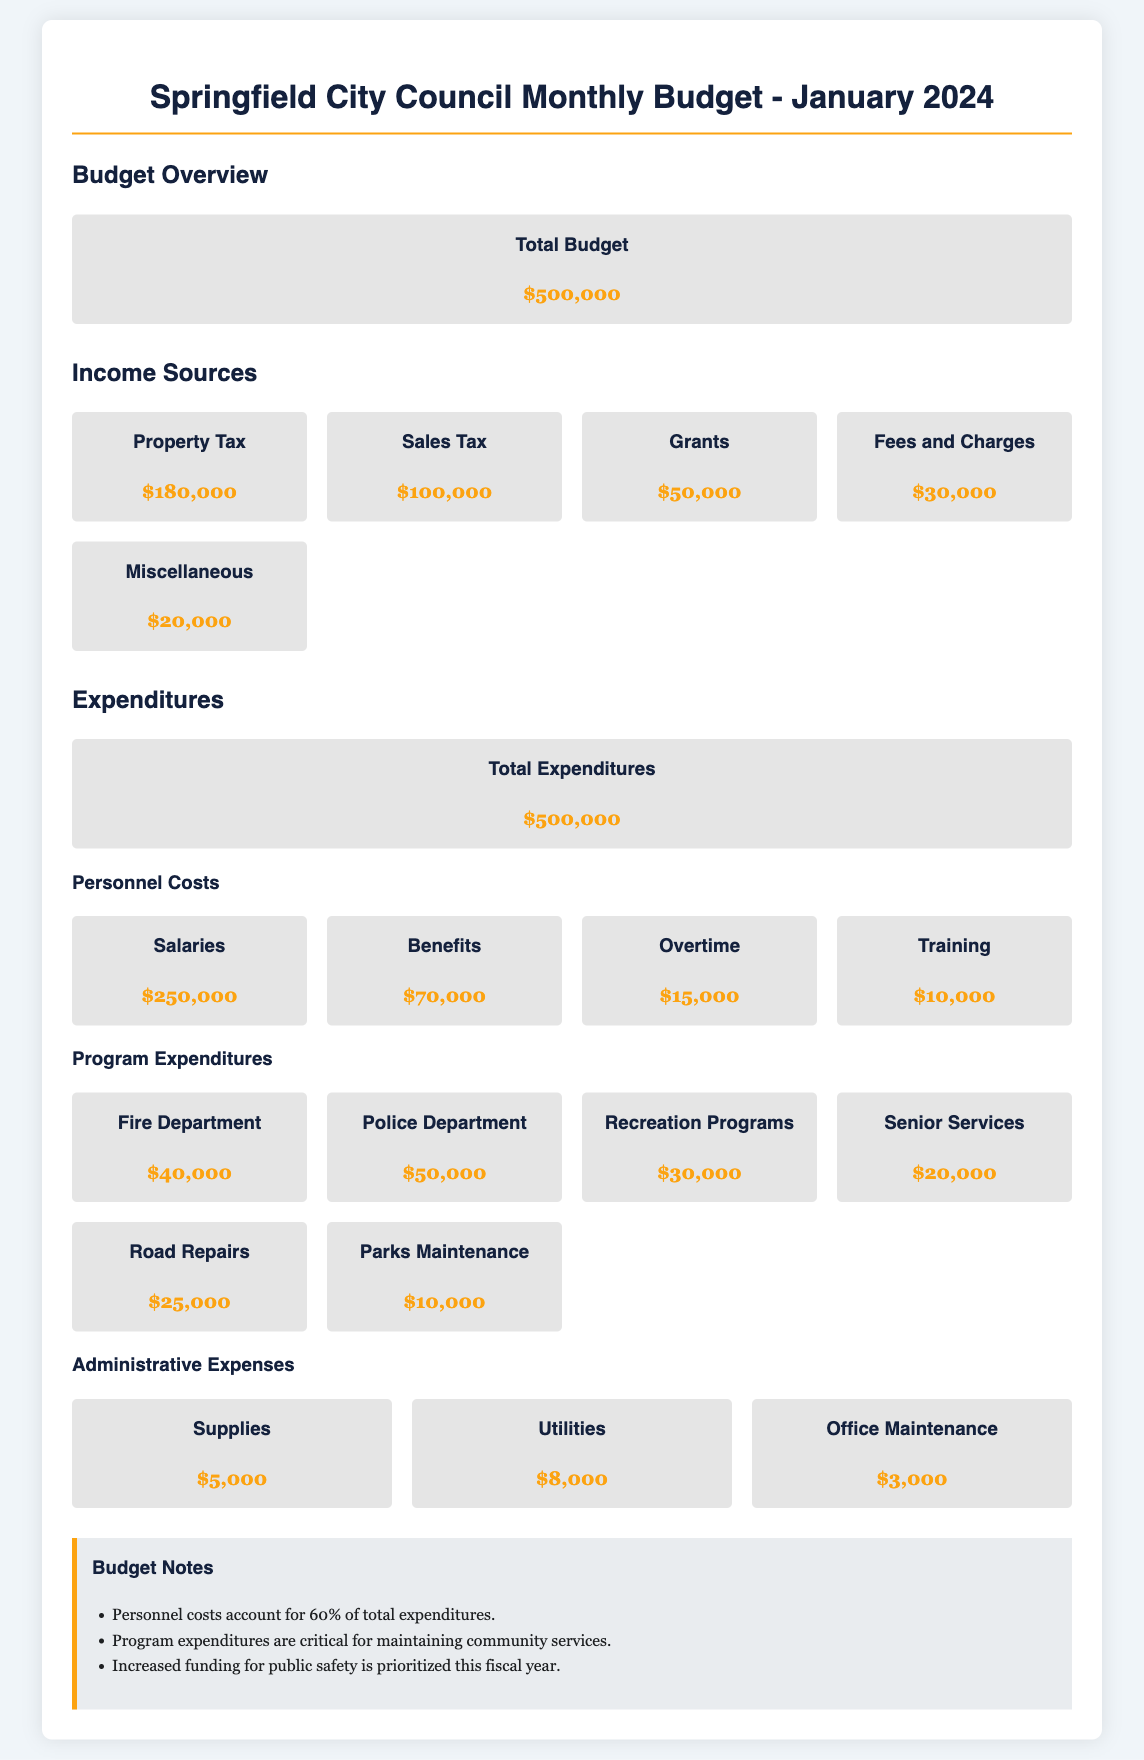What is the total budget? The total budget is stated in the document as $500,000.
Answer: $500,000 How much is allocated for salaries? The document lists salaries as one of the personnel costs at $250,000.
Answer: $250,000 What percentage of total expenditures do personnel costs account for? The budget notes indicate that personnel costs account for 60% of total expenditures.
Answer: 60% What is the total expenditure for the Police Department? The document specifies the Police Department's program expenditure as $50,000.
Answer: $50,000 What is the combined amount for benefits and overtime? By adding the benefits ($70,000) and overtime ($15,000) from personnel costs, the total is $85,000.
Answer: $85,000 How much is budgeted for Road Repairs? The allocated budget for Road Repairs is explicitly mentioned as $25,000 in the program expenditures section.
Answer: $25,000 What is the total amount spent on administrative expenses? Summing the administrative expenses ($5,000 + $8,000 + $3,000) gives a total of $16,000.
Answer: $16,000 What is the budget for training? The budget for training is specifically noted as $10,000 under personnel costs.
Answer: $10,000 How much funding is designated for recreation programs? The document provides the funding for recreation programs as $30,000 in the program expenditures.
Answer: $30,000 